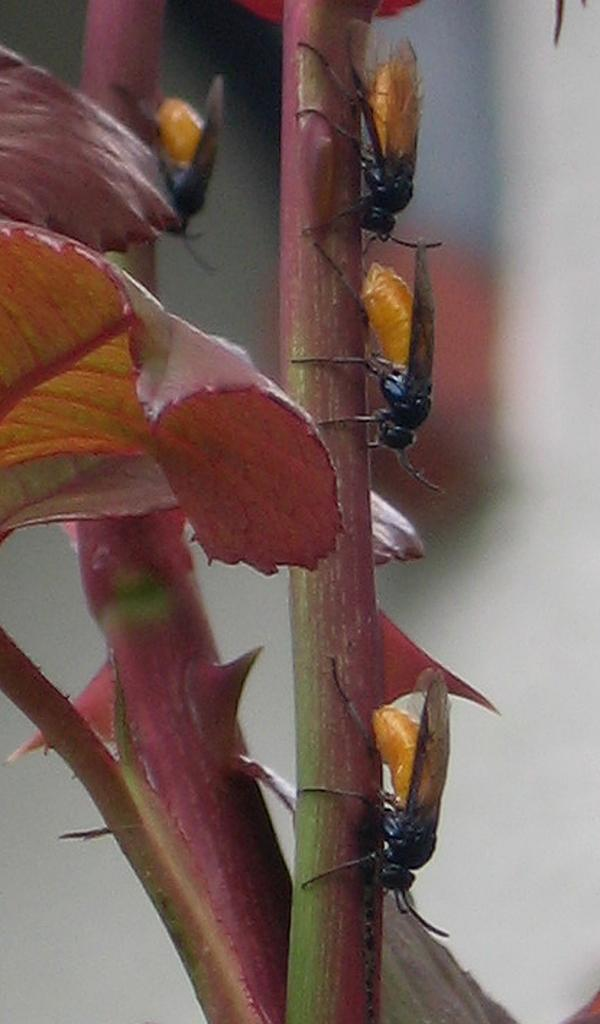What type of plant is visible in the image? There is a tree with leaves in the image. Are there any living organisms on the tree? Yes, there are insects on the tree. Can you describe the background of the image? The background of the image is blurred. What type of meat is being served at the seashore in the image? There is no seashore or meat present in the image; it features a tree with leaves and insects. 